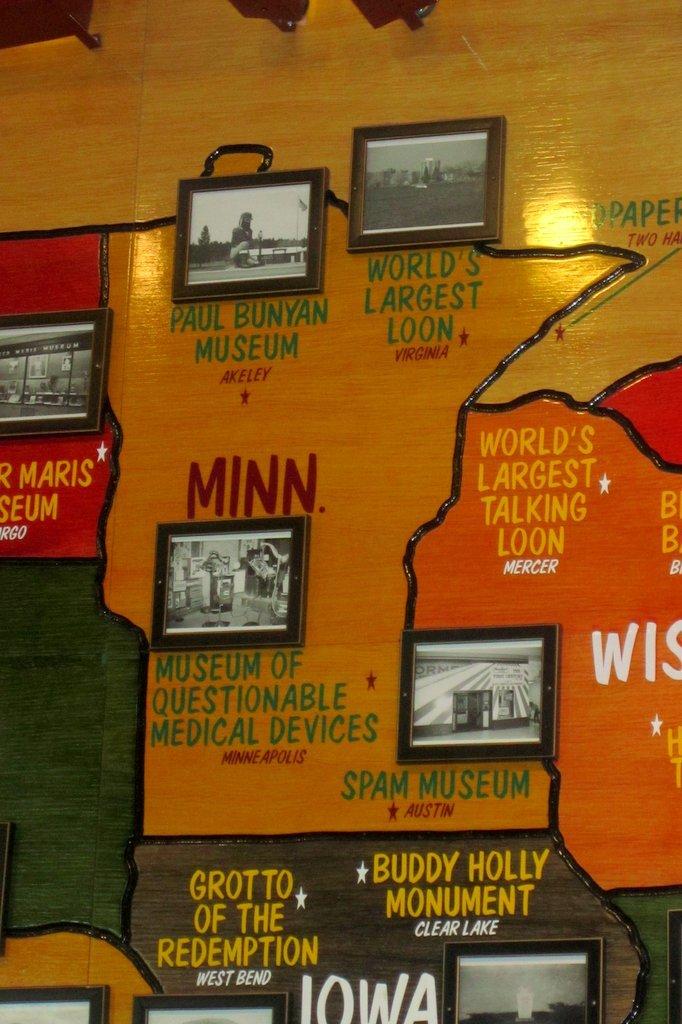In what city is the spam museum?
Keep it short and to the point. Austin. What monument is talked about on the wall?
Ensure brevity in your answer.  Buddy holly. 